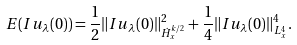<formula> <loc_0><loc_0><loc_500><loc_500>E ( I u _ { \lambda } ( 0 ) ) = \frac { 1 } { 2 } \| I u _ { \lambda } ( 0 ) \| ^ { 2 } _ { \dot { H } ^ { k / 2 } _ { x } } + \frac { 1 } { 4 } \| I u _ { \lambda } ( 0 ) \| ^ { 4 } _ { L ^ { 4 } _ { x } } .</formula> 